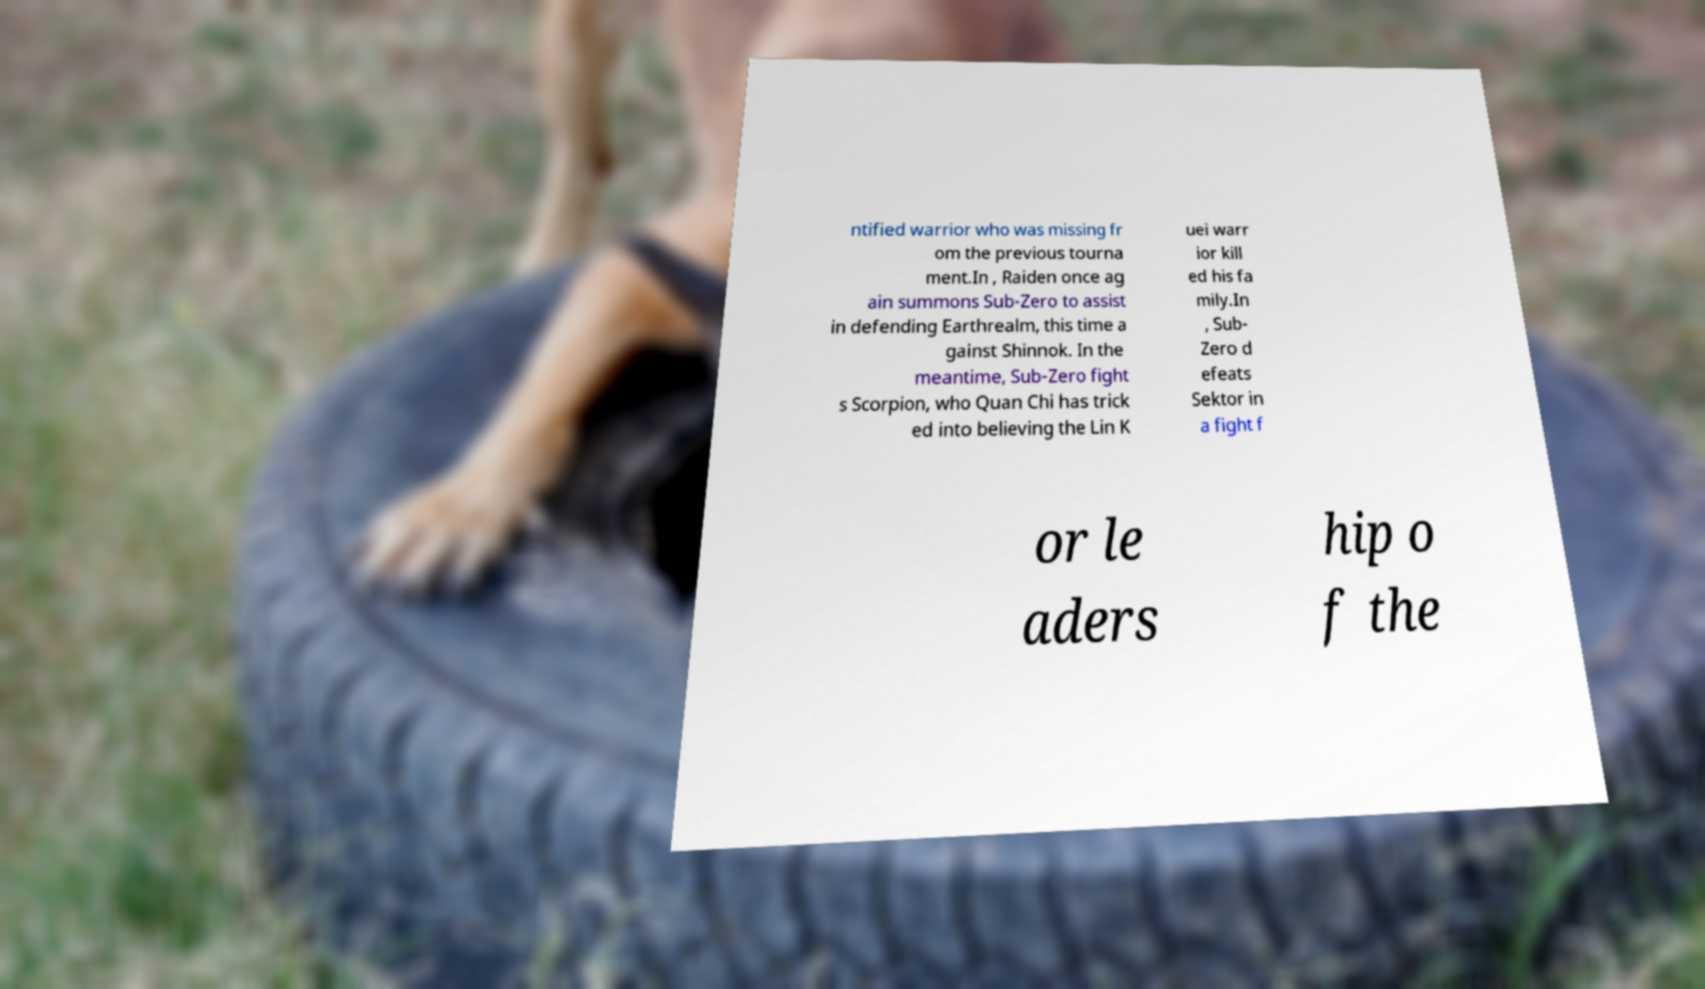Could you assist in decoding the text presented in this image and type it out clearly? ntified warrior who was missing fr om the previous tourna ment.In , Raiden once ag ain summons Sub-Zero to assist in defending Earthrealm, this time a gainst Shinnok. In the meantime, Sub-Zero fight s Scorpion, who Quan Chi has trick ed into believing the Lin K uei warr ior kill ed his fa mily.In , Sub- Zero d efeats Sektor in a fight f or le aders hip o f the 